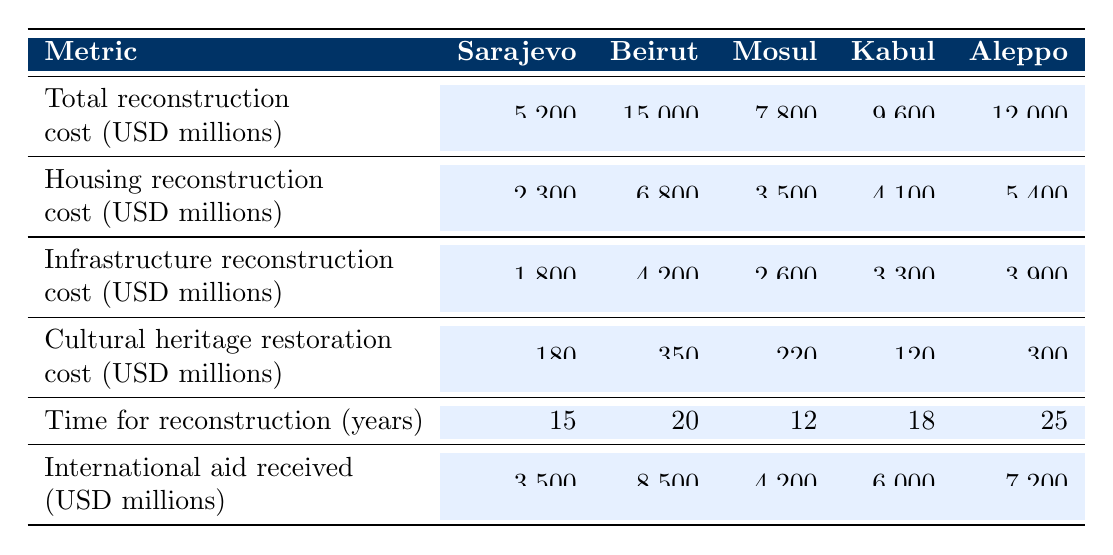What is the total reconstruction cost for Mosul? The total reconstruction cost for Mosul is explicitly listed in the table as 7,800 million USD.
Answer: 7,800 million USD Which city had the highest cultural heritage restoration cost? The highest cultural heritage restoration cost is found in Beirut at 350 million USD, compared to other cities listed.
Answer: Beirut What is the average housing reconstruction cost across all cities? To calculate the average, sum the housing reconstruction costs: (2,300 + 6,800 + 3,500 + 4,100 + 5,400) = 22,100 million USD. Then divide by the number of cities (5): 22,100 / 5 = 4,420 million USD.
Answer: 4,420 million USD Which city received the least international aid? The international aid received for each city is: Sarajevo (3,500), Beirut (8,500), Mosul (4,200), Kabul (6,000), Aleppo (7,200). The least international aid is received by Sarajevo.
Answer: Sarajevo What is the total reconstruction cost for Kabul and Aleppo combined? The total reconstruction costs for Kabul (9,600 million USD) and Aleppo (12,000 million USD) are summed as follows: 9,600 + 12,000 = 21,600 million USD.
Answer: 21,600 million USD Did Sarajevo receive more international aid than Aleppo? The international aid for Sarajevo is 3,500 million USD, while for Aleppo it is 7,200 million USD. Therefore, Sarajevo received less international aid than Aleppo.
Answer: No Which city had the most years for reconstruction? The table indicates that Aleppo had the longest time for reconstruction at 25 years compared to the other cities.
Answer: Aleppo What is the difference in housing reconstruction costs between Beirut and Mosul? The housing reconstruction cost for Beirut is 6,800 million USD, while for Mosul it's 3,500 million USD. The difference is calculated as 6,800 - 3,500 = 3,300 million USD.
Answer: 3,300 million USD What relationship can be observed between total reconstruction cost and international aid received? While observing the table, we see that cities with higher total reconstruction costs often received more international aid. For example, Beirut, with the highest reconstruction cost of 15,000 million USD, received 8,500 million USD in aid, indicating a positive relationship.
Answer: Generally positive relationship Is the infrastructure reconstruction cost for Mosul greater than the total reconstruction cost for Sarajevo? The infrastructure reconstruction cost for Mosul is 2,600 million USD, while the total reconstruction cost for Sarajevo is 5,200 million USD. Therefore, the infrastructure cost is not greater.
Answer: No 